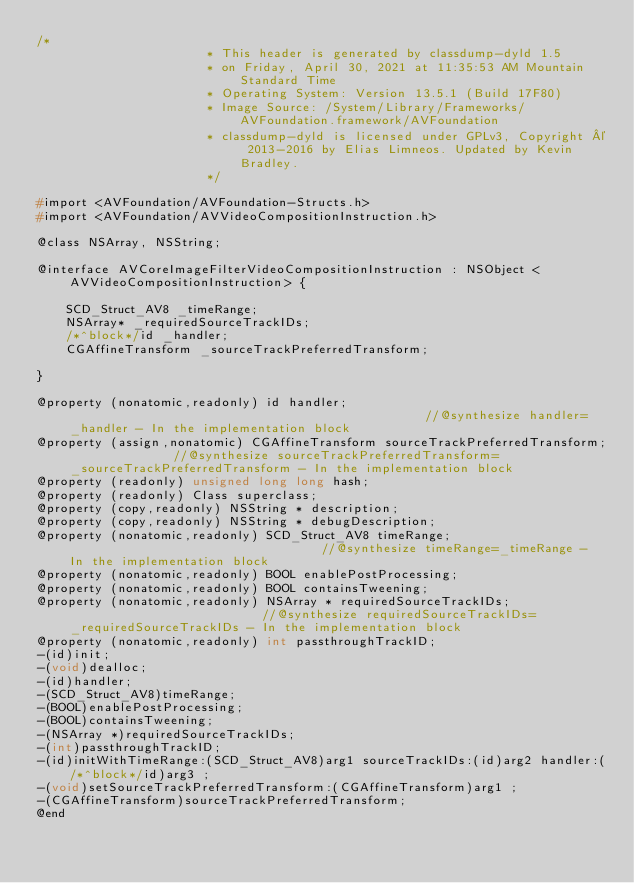<code> <loc_0><loc_0><loc_500><loc_500><_C_>/*
                       * This header is generated by classdump-dyld 1.5
                       * on Friday, April 30, 2021 at 11:35:53 AM Mountain Standard Time
                       * Operating System: Version 13.5.1 (Build 17F80)
                       * Image Source: /System/Library/Frameworks/AVFoundation.framework/AVFoundation
                       * classdump-dyld is licensed under GPLv3, Copyright © 2013-2016 by Elias Limneos. Updated by Kevin Bradley.
                       */

#import <AVFoundation/AVFoundation-Structs.h>
#import <AVFoundation/AVVideoCompositionInstruction.h>

@class NSArray, NSString;

@interface AVCoreImageFilterVideoCompositionInstruction : NSObject <AVVideoCompositionInstruction> {

	SCD_Struct_AV8 _timeRange;
	NSArray* _requiredSourceTrackIDs;
	/*^block*/id _handler;
	CGAffineTransform _sourceTrackPreferredTransform;

}

@property (nonatomic,readonly) id handler;                                                 //@synthesize handler=_handler - In the implementation block
@property (assign,nonatomic) CGAffineTransform sourceTrackPreferredTransform;              //@synthesize sourceTrackPreferredTransform=_sourceTrackPreferredTransform - In the implementation block
@property (readonly) unsigned long long hash; 
@property (readonly) Class superclass; 
@property (copy,readonly) NSString * description; 
@property (copy,readonly) NSString * debugDescription; 
@property (nonatomic,readonly) SCD_Struct_AV8 timeRange;                                   //@synthesize timeRange=_timeRange - In the implementation block
@property (nonatomic,readonly) BOOL enablePostProcessing; 
@property (nonatomic,readonly) BOOL containsTweening; 
@property (nonatomic,readonly) NSArray * requiredSourceTrackIDs;                           //@synthesize requiredSourceTrackIDs=_requiredSourceTrackIDs - In the implementation block
@property (nonatomic,readonly) int passthroughTrackID; 
-(id)init;
-(void)dealloc;
-(id)handler;
-(SCD_Struct_AV8)timeRange;
-(BOOL)enablePostProcessing;
-(BOOL)containsTweening;
-(NSArray *)requiredSourceTrackIDs;
-(int)passthroughTrackID;
-(id)initWithTimeRange:(SCD_Struct_AV8)arg1 sourceTrackIDs:(id)arg2 handler:(/*^block*/id)arg3 ;
-(void)setSourceTrackPreferredTransform:(CGAffineTransform)arg1 ;
-(CGAffineTransform)sourceTrackPreferredTransform;
@end

</code> 